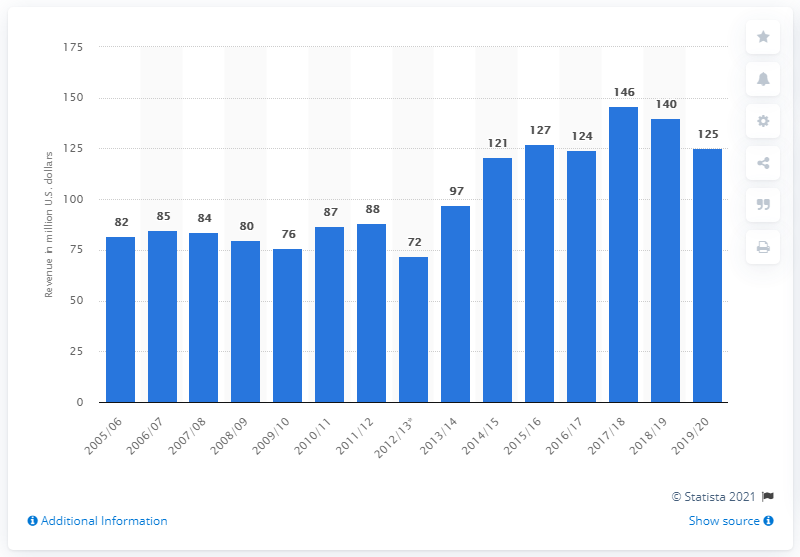Identify some key points in this picture. The Tampa Bay Lightning's revenue for the 2019/20 season was $125 million. 